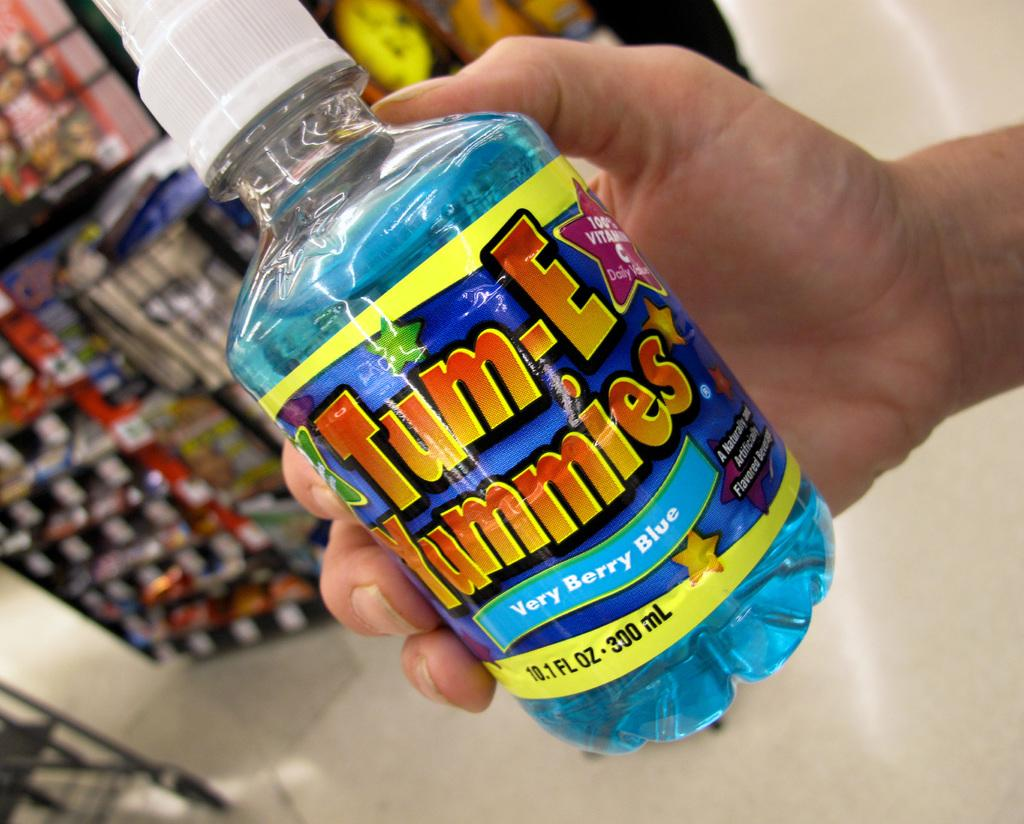What color is the bottle that is visible in the image? There is a blue bottle in the image. What is the bottle being held by in the image? The blue bottle is being held by a human hand. What type of confectionery can be seen in the image? There are candies visible in the image. Where are the candies located in the image? The candies are in a store. What is the daughter's name of the person holding the blue bottle in the image? There is no information about a daughter or any person's name in the image. How many boys are visible in the image? There are no boys visible in the image. 